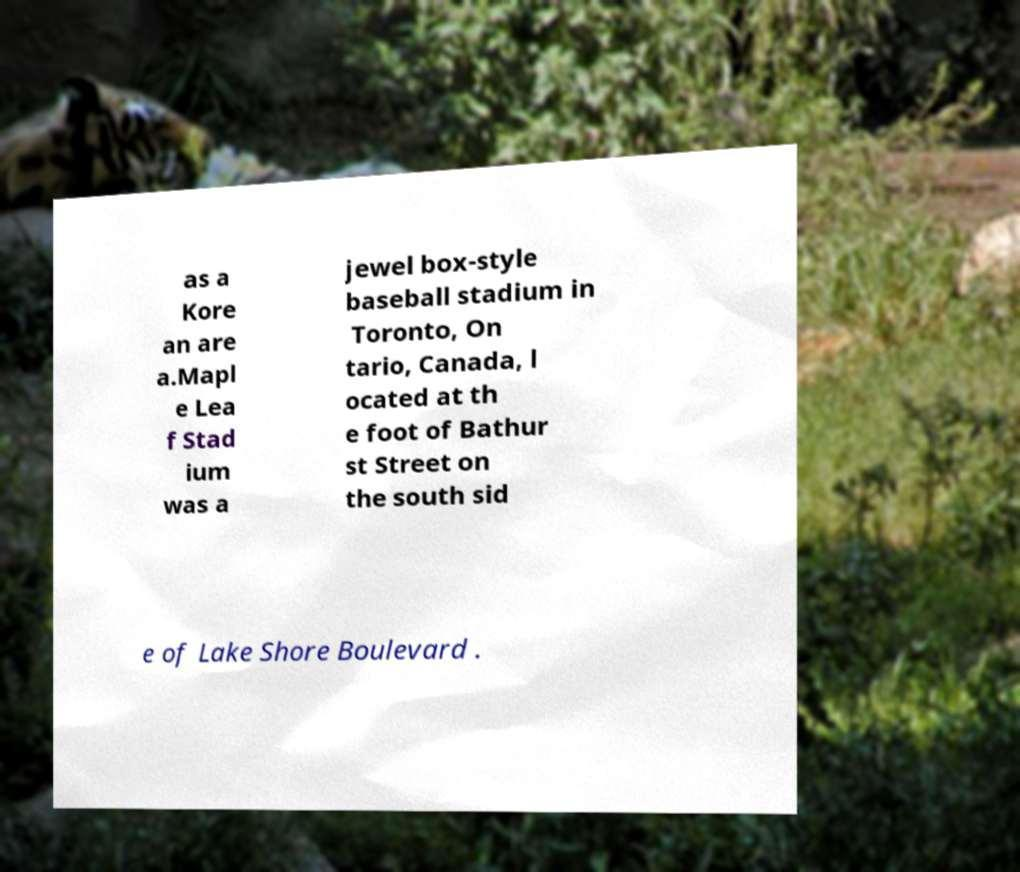Could you extract and type out the text from this image? as a Kore an are a.Mapl e Lea f Stad ium was a jewel box-style baseball stadium in Toronto, On tario, Canada, l ocated at th e foot of Bathur st Street on the south sid e of Lake Shore Boulevard . 